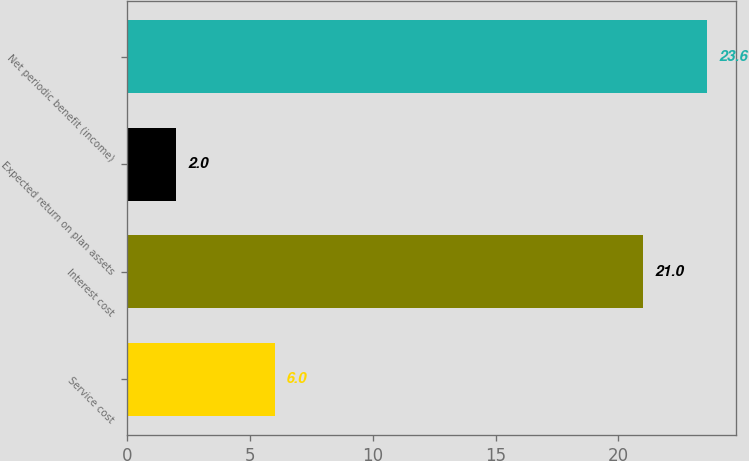Convert chart. <chart><loc_0><loc_0><loc_500><loc_500><bar_chart><fcel>Service cost<fcel>Interest cost<fcel>Expected return on plan assets<fcel>Net periodic benefit (income)<nl><fcel>6<fcel>21<fcel>2<fcel>23.6<nl></chart> 